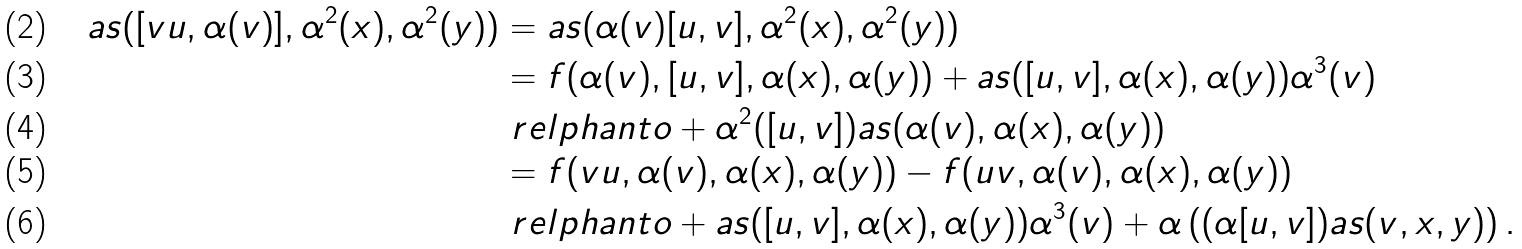<formula> <loc_0><loc_0><loc_500><loc_500>a s ( [ v u , \alpha ( v ) ] , \alpha ^ { 2 } ( x ) , \alpha ^ { 2 } ( y ) ) & = a s ( \alpha ( v ) [ u , v ] , \alpha ^ { 2 } ( x ) , \alpha ^ { 2 } ( y ) ) \\ & = f ( \alpha ( v ) , [ u , v ] , \alpha ( x ) , \alpha ( y ) ) + a s ( [ u , v ] , \alpha ( x ) , \alpha ( y ) ) \alpha ^ { 3 } ( v ) \\ & \ r e l p h a n t o + \alpha ^ { 2 } ( [ u , v ] ) a s ( \alpha ( v ) , \alpha ( x ) , \alpha ( y ) ) \\ & = f ( v u , \alpha ( v ) , \alpha ( x ) , \alpha ( y ) ) - f ( u v , \alpha ( v ) , \alpha ( x ) , \alpha ( y ) ) \\ & \ r e l p h a n t o + a s ( [ u , v ] , \alpha ( x ) , \alpha ( y ) ) \alpha ^ { 3 } ( v ) + \alpha \left ( ( \alpha [ u , v ] ) a s ( v , x , y ) \right ) .</formula> 